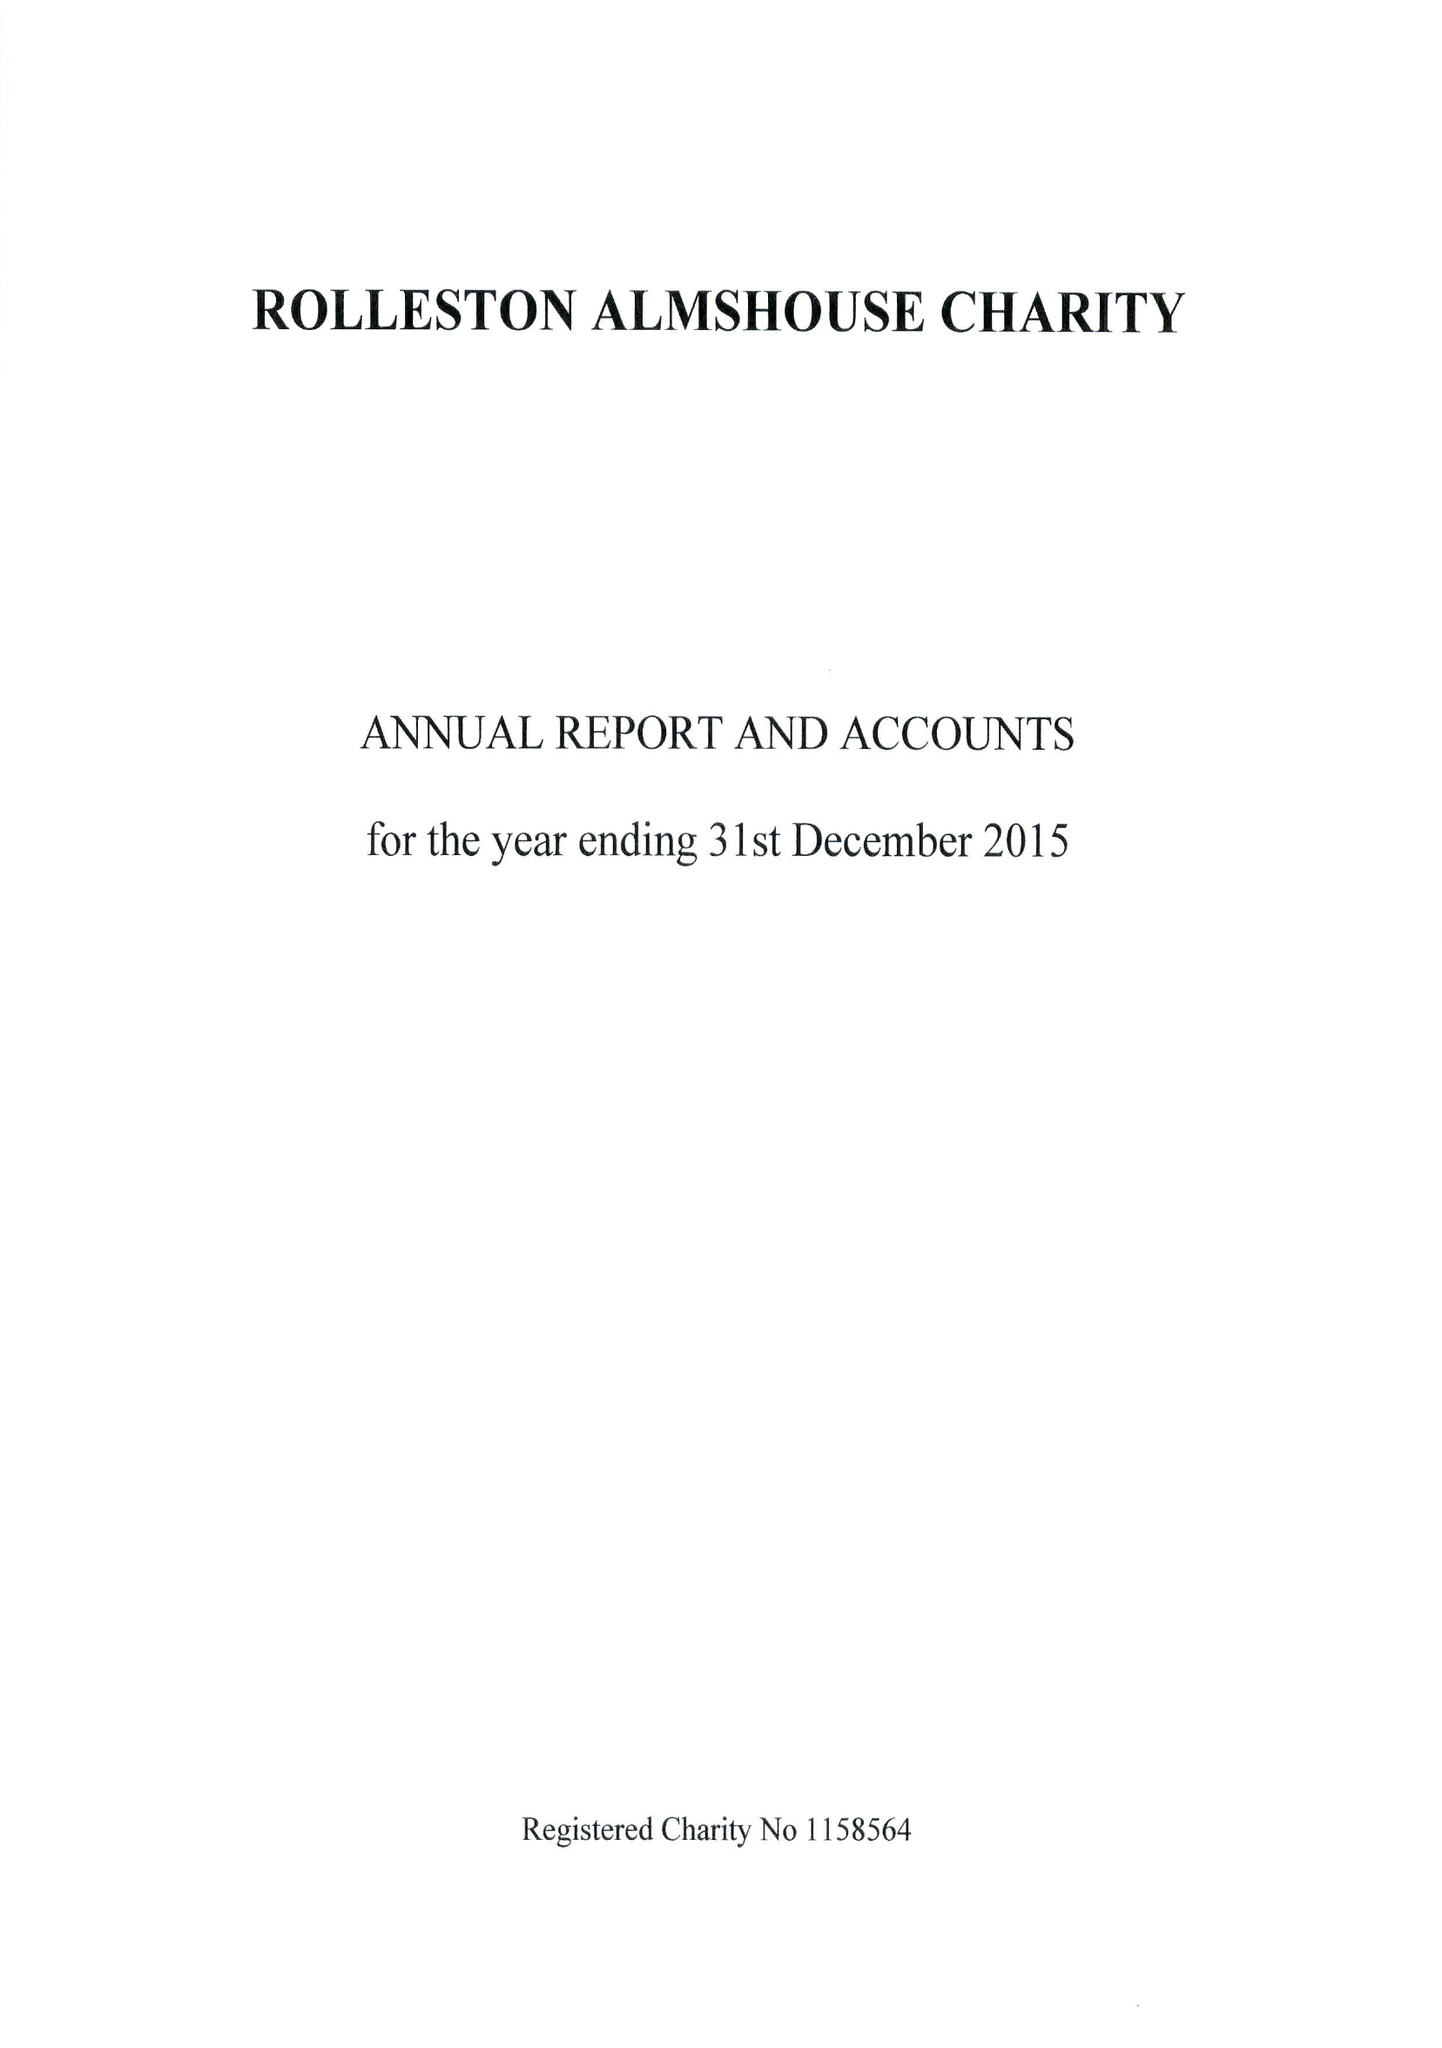What is the value for the income_annually_in_british_pounds?
Answer the question using a single word or phrase. 31865.00 